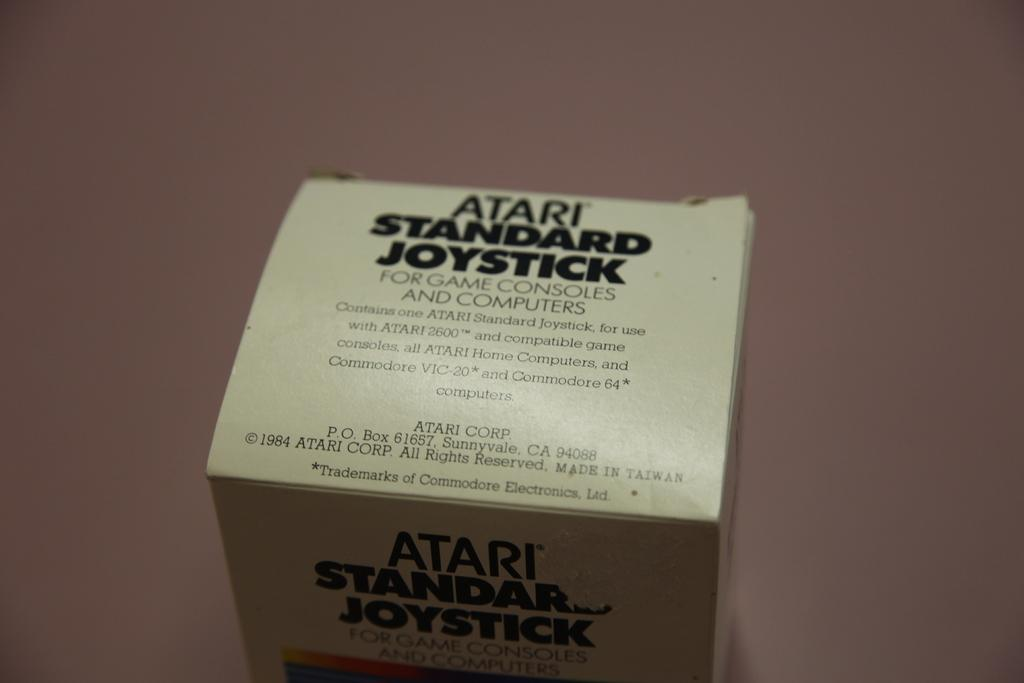<image>
Summarize the visual content of the image. A box saying it contains an Atari standard joystick. 